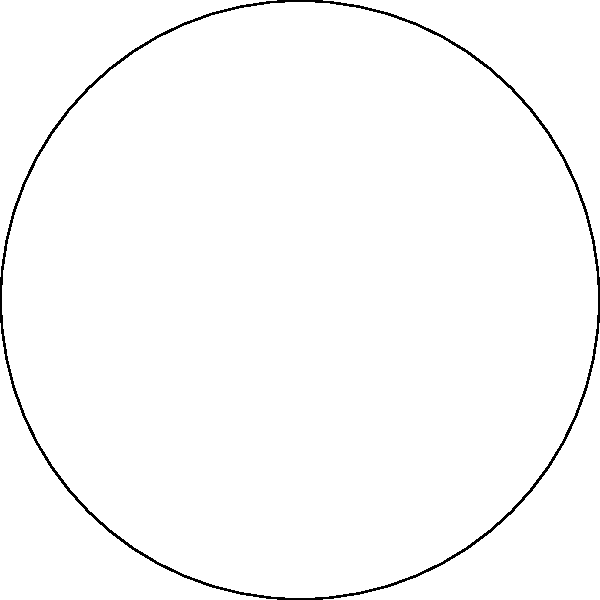In your historical fiction novel, you've created a pie chart to represent the distribution of time spent in different historical eras. If the Medieval era occupies 120 degrees of the chart, what is the central angle for the Renaissance period? To solve this problem, we'll follow these steps:

1) First, we need to understand that a full circle has 360 degrees.

2) We're given that the Medieval era occupies 120 degrees.

3) From the pie chart, we can see that there are four eras in total: Medieval, Renaissance, Enlightenment, and Industrial.

4) We can observe that the Renaissance and Industrial eras appear to occupy the same amount of space in the chart.

5) The Enlightenment era appears to occupy less space than the Renaissance and Industrial eras.

6) Given this information, we can set up an equation:

   $120 + x + y + x = 360$, where $x$ is the angle for Renaissance (and Industrial), and $y$ is the angle for Enlightenment.

7) We can simplify this to: $120 + 2x + y = 360$

8) From the chart, we can estimate that the Enlightenment era ($y$) is about 2/3 the size of the Renaissance era ($x$).

   So, $y = \frac{2}{3}x$

9) Substituting this into our equation:

   $120 + 2x + \frac{2}{3}x = 360$
   $120 + \frac{8}{3}x = 360$

10) Solving for $x$:

    $\frac{8}{3}x = 240$
    $x = 90$

Therefore, the central angle for the Renaissance period is 90 degrees.
Answer: 90 degrees 